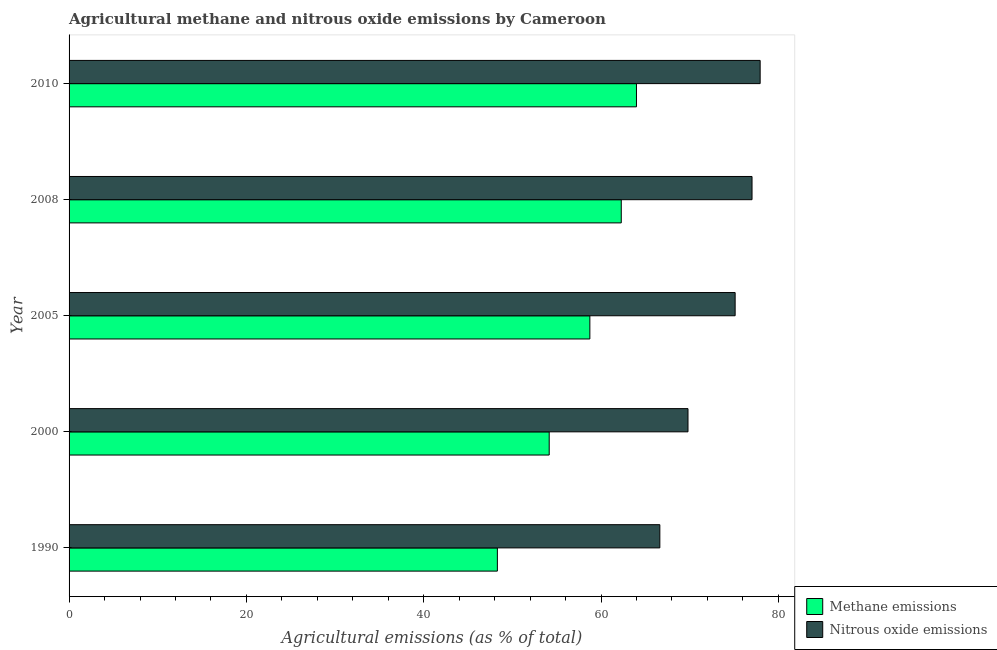Are the number of bars per tick equal to the number of legend labels?
Your answer should be very brief. Yes. How many bars are there on the 3rd tick from the top?
Keep it short and to the point. 2. How many bars are there on the 4th tick from the bottom?
Provide a succinct answer. 2. In how many cases, is the number of bars for a given year not equal to the number of legend labels?
Provide a short and direct response. 0. What is the amount of nitrous oxide emissions in 2008?
Provide a succinct answer. 77.03. Across all years, what is the maximum amount of nitrous oxide emissions?
Offer a terse response. 77.95. Across all years, what is the minimum amount of methane emissions?
Your answer should be compact. 48.31. In which year was the amount of methane emissions maximum?
Your answer should be very brief. 2010. In which year was the amount of nitrous oxide emissions minimum?
Provide a succinct answer. 1990. What is the total amount of methane emissions in the graph?
Make the answer very short. 287.48. What is the difference between the amount of nitrous oxide emissions in 2000 and that in 2010?
Ensure brevity in your answer.  -8.14. What is the difference between the amount of methane emissions in 2000 and the amount of nitrous oxide emissions in 2005?
Provide a succinct answer. -20.97. What is the average amount of methane emissions per year?
Ensure brevity in your answer.  57.5. In the year 2008, what is the difference between the amount of methane emissions and amount of nitrous oxide emissions?
Make the answer very short. -14.75. In how many years, is the amount of nitrous oxide emissions greater than 4 %?
Provide a succinct answer. 5. What is the ratio of the amount of methane emissions in 1990 to that in 2005?
Make the answer very short. 0.82. Is the amount of methane emissions in 1990 less than that in 2008?
Make the answer very short. Yes. What is the difference between the highest and the second highest amount of nitrous oxide emissions?
Your answer should be very brief. 0.92. What is the difference between the highest and the lowest amount of nitrous oxide emissions?
Offer a terse response. 11.31. In how many years, is the amount of nitrous oxide emissions greater than the average amount of nitrous oxide emissions taken over all years?
Your answer should be compact. 3. What does the 2nd bar from the top in 2005 represents?
Your answer should be compact. Methane emissions. What does the 2nd bar from the bottom in 2005 represents?
Give a very brief answer. Nitrous oxide emissions. How many bars are there?
Your answer should be compact. 10. Are all the bars in the graph horizontal?
Offer a very short reply. Yes. How many years are there in the graph?
Make the answer very short. 5. Are the values on the major ticks of X-axis written in scientific E-notation?
Ensure brevity in your answer.  No. Does the graph contain any zero values?
Provide a short and direct response. No. Where does the legend appear in the graph?
Your answer should be very brief. Bottom right. How are the legend labels stacked?
Offer a very short reply. Vertical. What is the title of the graph?
Your answer should be very brief. Agricultural methane and nitrous oxide emissions by Cameroon. Does "Arms imports" appear as one of the legend labels in the graph?
Your answer should be compact. No. What is the label or title of the X-axis?
Make the answer very short. Agricultural emissions (as % of total). What is the Agricultural emissions (as % of total) in Methane emissions in 1990?
Your answer should be compact. 48.31. What is the Agricultural emissions (as % of total) in Nitrous oxide emissions in 1990?
Make the answer very short. 66.63. What is the Agricultural emissions (as % of total) of Methane emissions in 2000?
Keep it short and to the point. 54.15. What is the Agricultural emissions (as % of total) in Nitrous oxide emissions in 2000?
Keep it short and to the point. 69.81. What is the Agricultural emissions (as % of total) of Methane emissions in 2005?
Offer a terse response. 58.74. What is the Agricultural emissions (as % of total) in Nitrous oxide emissions in 2005?
Give a very brief answer. 75.13. What is the Agricultural emissions (as % of total) of Methane emissions in 2008?
Ensure brevity in your answer.  62.28. What is the Agricultural emissions (as % of total) of Nitrous oxide emissions in 2008?
Your answer should be very brief. 77.03. What is the Agricultural emissions (as % of total) in Methane emissions in 2010?
Give a very brief answer. 64. What is the Agricultural emissions (as % of total) of Nitrous oxide emissions in 2010?
Give a very brief answer. 77.95. Across all years, what is the maximum Agricultural emissions (as % of total) in Methane emissions?
Provide a succinct answer. 64. Across all years, what is the maximum Agricultural emissions (as % of total) of Nitrous oxide emissions?
Keep it short and to the point. 77.95. Across all years, what is the minimum Agricultural emissions (as % of total) of Methane emissions?
Your response must be concise. 48.31. Across all years, what is the minimum Agricultural emissions (as % of total) in Nitrous oxide emissions?
Offer a terse response. 66.63. What is the total Agricultural emissions (as % of total) in Methane emissions in the graph?
Your answer should be compact. 287.48. What is the total Agricultural emissions (as % of total) of Nitrous oxide emissions in the graph?
Offer a terse response. 366.55. What is the difference between the Agricultural emissions (as % of total) in Methane emissions in 1990 and that in 2000?
Your response must be concise. -5.85. What is the difference between the Agricultural emissions (as % of total) of Nitrous oxide emissions in 1990 and that in 2000?
Make the answer very short. -3.18. What is the difference between the Agricultural emissions (as % of total) in Methane emissions in 1990 and that in 2005?
Offer a very short reply. -10.43. What is the difference between the Agricultural emissions (as % of total) in Nitrous oxide emissions in 1990 and that in 2005?
Make the answer very short. -8.49. What is the difference between the Agricultural emissions (as % of total) in Methane emissions in 1990 and that in 2008?
Ensure brevity in your answer.  -13.97. What is the difference between the Agricultural emissions (as % of total) of Nitrous oxide emissions in 1990 and that in 2008?
Offer a terse response. -10.4. What is the difference between the Agricultural emissions (as % of total) in Methane emissions in 1990 and that in 2010?
Give a very brief answer. -15.69. What is the difference between the Agricultural emissions (as % of total) of Nitrous oxide emissions in 1990 and that in 2010?
Your answer should be compact. -11.31. What is the difference between the Agricultural emissions (as % of total) in Methane emissions in 2000 and that in 2005?
Give a very brief answer. -4.59. What is the difference between the Agricultural emissions (as % of total) in Nitrous oxide emissions in 2000 and that in 2005?
Give a very brief answer. -5.32. What is the difference between the Agricultural emissions (as % of total) of Methane emissions in 2000 and that in 2008?
Give a very brief answer. -8.13. What is the difference between the Agricultural emissions (as % of total) in Nitrous oxide emissions in 2000 and that in 2008?
Provide a short and direct response. -7.22. What is the difference between the Agricultural emissions (as % of total) in Methane emissions in 2000 and that in 2010?
Your response must be concise. -9.84. What is the difference between the Agricultural emissions (as % of total) in Nitrous oxide emissions in 2000 and that in 2010?
Your answer should be compact. -8.14. What is the difference between the Agricultural emissions (as % of total) of Methane emissions in 2005 and that in 2008?
Make the answer very short. -3.54. What is the difference between the Agricultural emissions (as % of total) in Nitrous oxide emissions in 2005 and that in 2008?
Ensure brevity in your answer.  -1.9. What is the difference between the Agricultural emissions (as % of total) of Methane emissions in 2005 and that in 2010?
Your answer should be very brief. -5.26. What is the difference between the Agricultural emissions (as % of total) of Nitrous oxide emissions in 2005 and that in 2010?
Provide a succinct answer. -2.82. What is the difference between the Agricultural emissions (as % of total) of Methane emissions in 2008 and that in 2010?
Your response must be concise. -1.71. What is the difference between the Agricultural emissions (as % of total) in Nitrous oxide emissions in 2008 and that in 2010?
Give a very brief answer. -0.92. What is the difference between the Agricultural emissions (as % of total) of Methane emissions in 1990 and the Agricultural emissions (as % of total) of Nitrous oxide emissions in 2000?
Keep it short and to the point. -21.5. What is the difference between the Agricultural emissions (as % of total) in Methane emissions in 1990 and the Agricultural emissions (as % of total) in Nitrous oxide emissions in 2005?
Your answer should be compact. -26.82. What is the difference between the Agricultural emissions (as % of total) in Methane emissions in 1990 and the Agricultural emissions (as % of total) in Nitrous oxide emissions in 2008?
Provide a short and direct response. -28.72. What is the difference between the Agricultural emissions (as % of total) in Methane emissions in 1990 and the Agricultural emissions (as % of total) in Nitrous oxide emissions in 2010?
Your response must be concise. -29.64. What is the difference between the Agricultural emissions (as % of total) in Methane emissions in 2000 and the Agricultural emissions (as % of total) in Nitrous oxide emissions in 2005?
Your response must be concise. -20.97. What is the difference between the Agricultural emissions (as % of total) of Methane emissions in 2000 and the Agricultural emissions (as % of total) of Nitrous oxide emissions in 2008?
Your answer should be compact. -22.88. What is the difference between the Agricultural emissions (as % of total) of Methane emissions in 2000 and the Agricultural emissions (as % of total) of Nitrous oxide emissions in 2010?
Provide a succinct answer. -23.79. What is the difference between the Agricultural emissions (as % of total) of Methane emissions in 2005 and the Agricultural emissions (as % of total) of Nitrous oxide emissions in 2008?
Your response must be concise. -18.29. What is the difference between the Agricultural emissions (as % of total) of Methane emissions in 2005 and the Agricultural emissions (as % of total) of Nitrous oxide emissions in 2010?
Offer a very short reply. -19.21. What is the difference between the Agricultural emissions (as % of total) in Methane emissions in 2008 and the Agricultural emissions (as % of total) in Nitrous oxide emissions in 2010?
Your answer should be very brief. -15.67. What is the average Agricultural emissions (as % of total) of Methane emissions per year?
Provide a succinct answer. 57.5. What is the average Agricultural emissions (as % of total) in Nitrous oxide emissions per year?
Keep it short and to the point. 73.31. In the year 1990, what is the difference between the Agricultural emissions (as % of total) of Methane emissions and Agricultural emissions (as % of total) of Nitrous oxide emissions?
Your answer should be very brief. -18.32. In the year 2000, what is the difference between the Agricultural emissions (as % of total) in Methane emissions and Agricultural emissions (as % of total) in Nitrous oxide emissions?
Give a very brief answer. -15.66. In the year 2005, what is the difference between the Agricultural emissions (as % of total) in Methane emissions and Agricultural emissions (as % of total) in Nitrous oxide emissions?
Offer a terse response. -16.39. In the year 2008, what is the difference between the Agricultural emissions (as % of total) in Methane emissions and Agricultural emissions (as % of total) in Nitrous oxide emissions?
Offer a very short reply. -14.75. In the year 2010, what is the difference between the Agricultural emissions (as % of total) of Methane emissions and Agricultural emissions (as % of total) of Nitrous oxide emissions?
Offer a terse response. -13.95. What is the ratio of the Agricultural emissions (as % of total) in Methane emissions in 1990 to that in 2000?
Provide a succinct answer. 0.89. What is the ratio of the Agricultural emissions (as % of total) of Nitrous oxide emissions in 1990 to that in 2000?
Ensure brevity in your answer.  0.95. What is the ratio of the Agricultural emissions (as % of total) in Methane emissions in 1990 to that in 2005?
Offer a very short reply. 0.82. What is the ratio of the Agricultural emissions (as % of total) of Nitrous oxide emissions in 1990 to that in 2005?
Your response must be concise. 0.89. What is the ratio of the Agricultural emissions (as % of total) of Methane emissions in 1990 to that in 2008?
Ensure brevity in your answer.  0.78. What is the ratio of the Agricultural emissions (as % of total) of Nitrous oxide emissions in 1990 to that in 2008?
Your answer should be compact. 0.86. What is the ratio of the Agricultural emissions (as % of total) in Methane emissions in 1990 to that in 2010?
Give a very brief answer. 0.75. What is the ratio of the Agricultural emissions (as % of total) of Nitrous oxide emissions in 1990 to that in 2010?
Keep it short and to the point. 0.85. What is the ratio of the Agricultural emissions (as % of total) in Methane emissions in 2000 to that in 2005?
Give a very brief answer. 0.92. What is the ratio of the Agricultural emissions (as % of total) of Nitrous oxide emissions in 2000 to that in 2005?
Your answer should be compact. 0.93. What is the ratio of the Agricultural emissions (as % of total) in Methane emissions in 2000 to that in 2008?
Offer a very short reply. 0.87. What is the ratio of the Agricultural emissions (as % of total) of Nitrous oxide emissions in 2000 to that in 2008?
Offer a terse response. 0.91. What is the ratio of the Agricultural emissions (as % of total) of Methane emissions in 2000 to that in 2010?
Give a very brief answer. 0.85. What is the ratio of the Agricultural emissions (as % of total) in Nitrous oxide emissions in 2000 to that in 2010?
Your response must be concise. 0.9. What is the ratio of the Agricultural emissions (as % of total) of Methane emissions in 2005 to that in 2008?
Give a very brief answer. 0.94. What is the ratio of the Agricultural emissions (as % of total) in Nitrous oxide emissions in 2005 to that in 2008?
Ensure brevity in your answer.  0.98. What is the ratio of the Agricultural emissions (as % of total) in Methane emissions in 2005 to that in 2010?
Offer a very short reply. 0.92. What is the ratio of the Agricultural emissions (as % of total) in Nitrous oxide emissions in 2005 to that in 2010?
Your answer should be compact. 0.96. What is the ratio of the Agricultural emissions (as % of total) of Methane emissions in 2008 to that in 2010?
Ensure brevity in your answer.  0.97. What is the ratio of the Agricultural emissions (as % of total) of Nitrous oxide emissions in 2008 to that in 2010?
Keep it short and to the point. 0.99. What is the difference between the highest and the second highest Agricultural emissions (as % of total) of Methane emissions?
Provide a short and direct response. 1.71. What is the difference between the highest and the second highest Agricultural emissions (as % of total) of Nitrous oxide emissions?
Your answer should be very brief. 0.92. What is the difference between the highest and the lowest Agricultural emissions (as % of total) of Methane emissions?
Provide a short and direct response. 15.69. What is the difference between the highest and the lowest Agricultural emissions (as % of total) in Nitrous oxide emissions?
Provide a succinct answer. 11.31. 